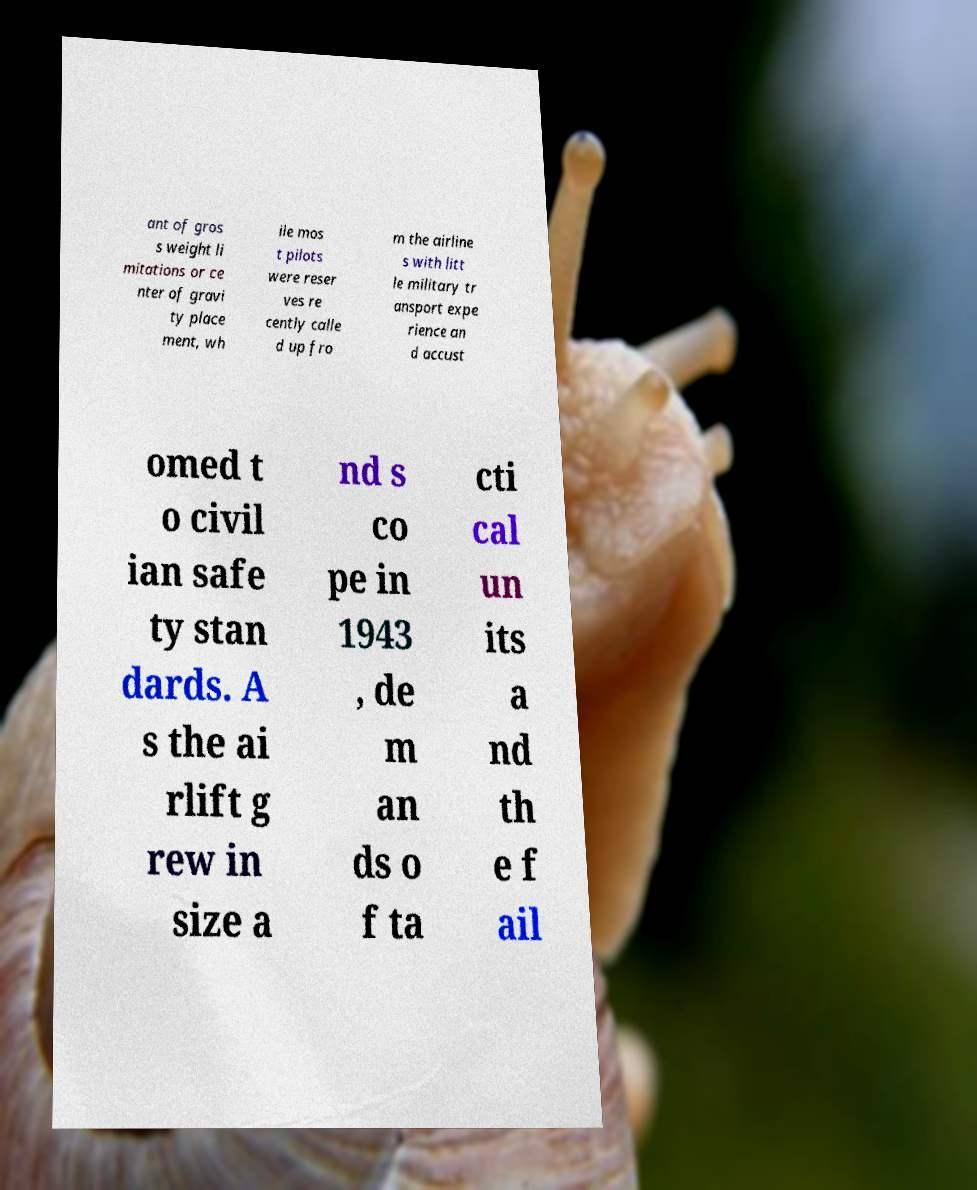Can you accurately transcribe the text from the provided image for me? ant of gros s weight li mitations or ce nter of gravi ty place ment, wh ile mos t pilots were reser ves re cently calle d up fro m the airline s with litt le military tr ansport expe rience an d accust omed t o civil ian safe ty stan dards. A s the ai rlift g rew in size a nd s co pe in 1943 , de m an ds o f ta cti cal un its a nd th e f ail 